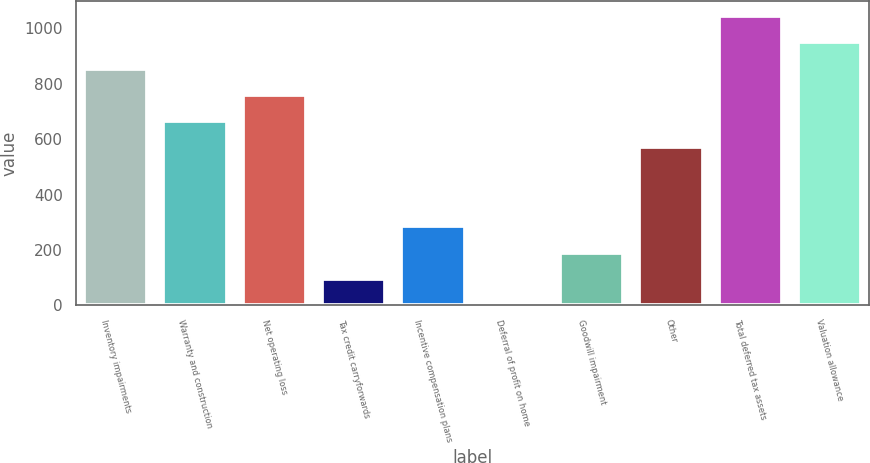Convert chart. <chart><loc_0><loc_0><loc_500><loc_500><bar_chart><fcel>Inventory impairments<fcel>Warranty and construction<fcel>Net operating loss<fcel>Tax credit carryforwards<fcel>Incentive compensation plans<fcel>Deferral of profit on home<fcel>Goodwill impairment<fcel>Other<fcel>Total deferred tax assets<fcel>Valuation allowance<nl><fcel>855.35<fcel>665.45<fcel>760.4<fcel>95.75<fcel>285.65<fcel>0.8<fcel>190.7<fcel>570.5<fcel>1045.25<fcel>950.3<nl></chart> 